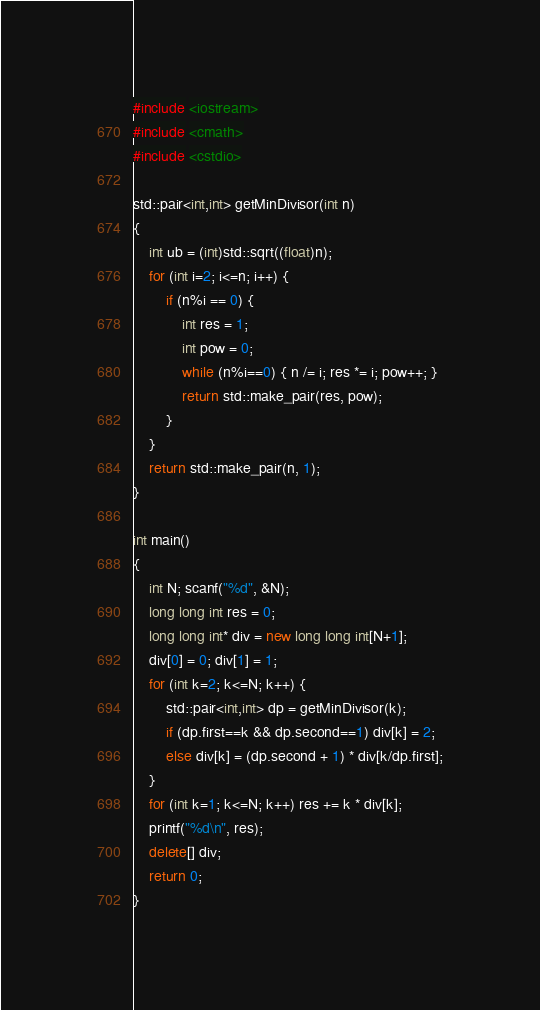<code> <loc_0><loc_0><loc_500><loc_500><_C++_>#include <iostream>
#include <cmath>
#include <cstdio>

std::pair<int,int> getMinDivisor(int n)
{
	int ub = (int)std::sqrt((float)n);
	for (int i=2; i<=n; i++) {
		if (n%i == 0) {
			int res = 1;
			int pow = 0;
			while (n%i==0) { n /= i; res *= i; pow++; }
			return std::make_pair(res, pow);
		}
	}
	return std::make_pair(n, 1);
}

int main()
{
	int N; scanf("%d", &N);
	long long int res = 0;
	long long int* div = new long long int[N+1];
	div[0] = 0; div[1] = 1;
	for (int k=2; k<=N; k++) {
		std::pair<int,int> dp = getMinDivisor(k);
		if (dp.first==k && dp.second==1) div[k] = 2;
		else div[k] = (dp.second + 1) * div[k/dp.first];
	}
	for (int k=1; k<=N; k++) res += k * div[k];
	printf("%d\n", res);
	delete[] div;
	return 0;
}</code> 